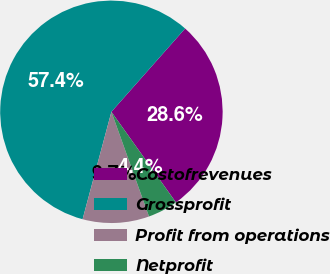Convert chart to OTSL. <chart><loc_0><loc_0><loc_500><loc_500><pie_chart><fcel>Costofrevenues<fcel>Grossprofit<fcel>Profit from operations<fcel>Netprofit<nl><fcel>28.62%<fcel>57.36%<fcel>9.66%<fcel>4.36%<nl></chart> 